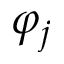<formula> <loc_0><loc_0><loc_500><loc_500>\varphi _ { j }</formula> 